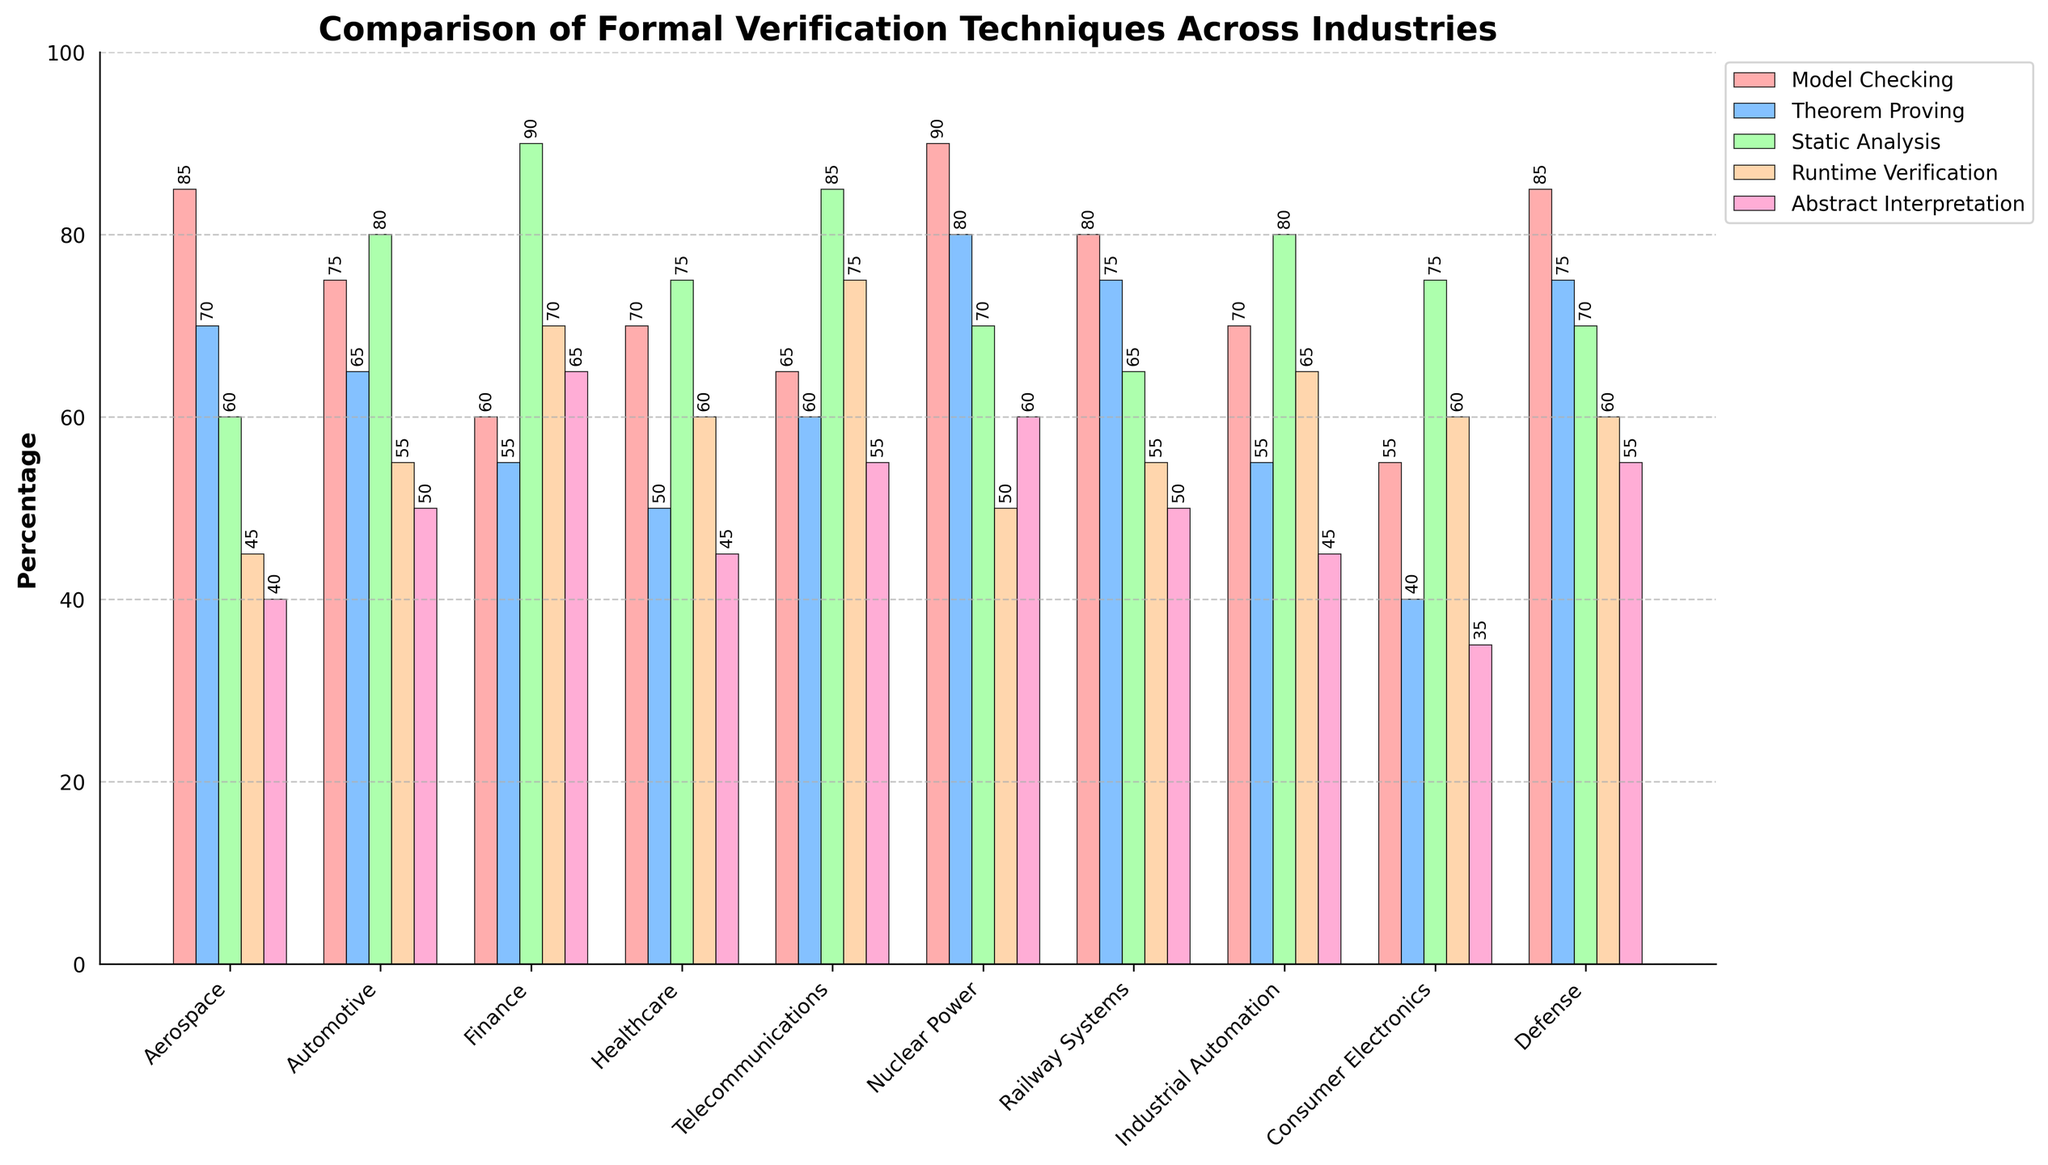What industry uses model checking the most? By looking at the chart, the industry with the highest bar for model checking should be selected. Here, the tallest bar for model checking is in the "Nuclear Power" sector.
Answer: Nuclear Power Which formal verification technique is most used in the finance industry? The tallest bar in the "Finance" group indicates the most used technique. For the finance industry, static analysis has the tallest bar.
Answer: Static Analysis Compare theorem proving usage between aerospace and automotive industries. Which one uses it more, and by how much percentage? The theorem proving bar for aerospace is at 70, and for automotive, it’s at 65. Subtract the latter from the former to find the difference (70 - 65).
Answer: Aerospace by 5% In which industry is runtime verification least used? The smallest runtime verification bar in the chart provides the answer. The consumer electronics industry has the shortest bar for runtime verification.
Answer: Consumer Electronics Which industry has the widest variety in the usage percentages of different formal verification techniques, as judged by the range between the highest and lowest values? Calculate the range (difference between the highest and lowest values) for each industry. The industry with the widest range has the highest difference.
Answer: Finance (90-55=35) Are there any industries that use static analysis less than 60%? If so, which ones? Scan the static analysis bars and identify those below the 60% mark. These industries are aerospace, healthcare, consumer electronics, and defense.
Answer: Aerospace, Healthcare, Consumer Electronics, Defense Which two industries have the closest percentage values for abstract interpretation? Compare the bars for abstract interpretation across industries to find those with the closest heights. The automotive and railway systems industries both have values of 50, indicating they are exactly the same.
Answer: Automotive, Railway Systems What is the average usage of model checking across all industries? Sum the model checking values (85+75+60+70+65+90+80+70+55+85 = 735) and divide by the number of industries (10).
Answer: 73.5 How does the usage of runtime verification in telecommunications compare to industrial automation? The telecommunications runtime verification bar is at 75, while industrial automation is at 65. Subtract the latter from the former (75 - 65).
Answer: Telecommunications by 10% Which industry has the most balanced usage percentages for all formal verification techniques? The most balanced would have the smallest difference between the highest and lowest values. The aerospace industry ranges from 40 to 85, a range of 45, which generally appears balanced.
Answer: Aerospace 